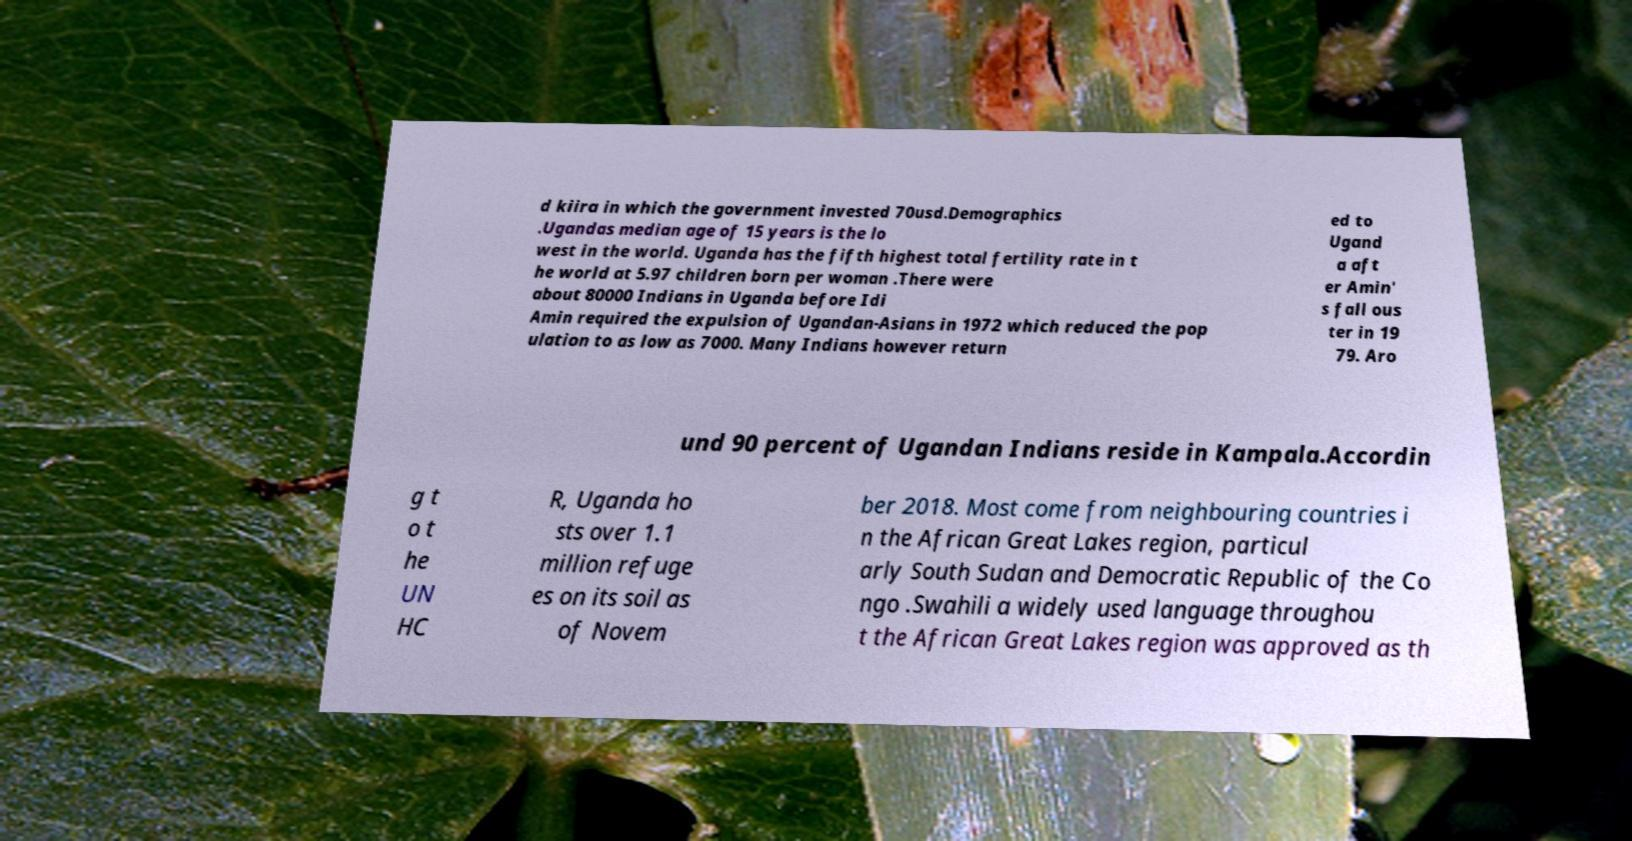Can you read and provide the text displayed in the image?This photo seems to have some interesting text. Can you extract and type it out for me? d kiira in which the government invested 70usd.Demographics .Ugandas median age of 15 years is the lo west in the world. Uganda has the fifth highest total fertility rate in t he world at 5.97 children born per woman .There were about 80000 Indians in Uganda before Idi Amin required the expulsion of Ugandan-Asians in 1972 which reduced the pop ulation to as low as 7000. Many Indians however return ed to Ugand a aft er Amin' s fall ous ter in 19 79. Aro und 90 percent of Ugandan Indians reside in Kampala.Accordin g t o t he UN HC R, Uganda ho sts over 1.1 million refuge es on its soil as of Novem ber 2018. Most come from neighbouring countries i n the African Great Lakes region, particul arly South Sudan and Democratic Republic of the Co ngo .Swahili a widely used language throughou t the African Great Lakes region was approved as th 